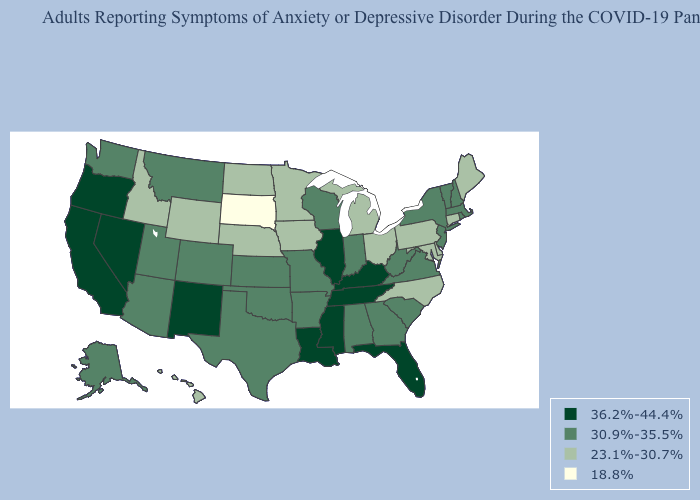What is the value of Hawaii?
Short answer required. 23.1%-30.7%. Does Delaware have a lower value than Maryland?
Write a very short answer. No. Which states have the lowest value in the South?
Write a very short answer. Delaware, Maryland, North Carolina. Does Minnesota have a lower value than Alabama?
Give a very brief answer. Yes. Name the states that have a value in the range 23.1%-30.7%?
Quick response, please. Connecticut, Delaware, Hawaii, Idaho, Iowa, Maine, Maryland, Michigan, Minnesota, Nebraska, North Carolina, North Dakota, Ohio, Pennsylvania, Wyoming. Name the states that have a value in the range 36.2%-44.4%?
Quick response, please. California, Florida, Illinois, Kentucky, Louisiana, Mississippi, Nevada, New Mexico, Oregon, Tennessee. Among the states that border Colorado , does New Mexico have the highest value?
Write a very short answer. Yes. What is the lowest value in states that border New Jersey?
Give a very brief answer. 23.1%-30.7%. How many symbols are there in the legend?
Be succinct. 4. Does the map have missing data?
Write a very short answer. No. Which states have the highest value in the USA?
Be succinct. California, Florida, Illinois, Kentucky, Louisiana, Mississippi, Nevada, New Mexico, Oregon, Tennessee. What is the lowest value in the MidWest?
Concise answer only. 18.8%. What is the value of South Carolina?
Be succinct. 30.9%-35.5%. What is the value of Maryland?
Be succinct. 23.1%-30.7%. What is the highest value in the USA?
Short answer required. 36.2%-44.4%. 